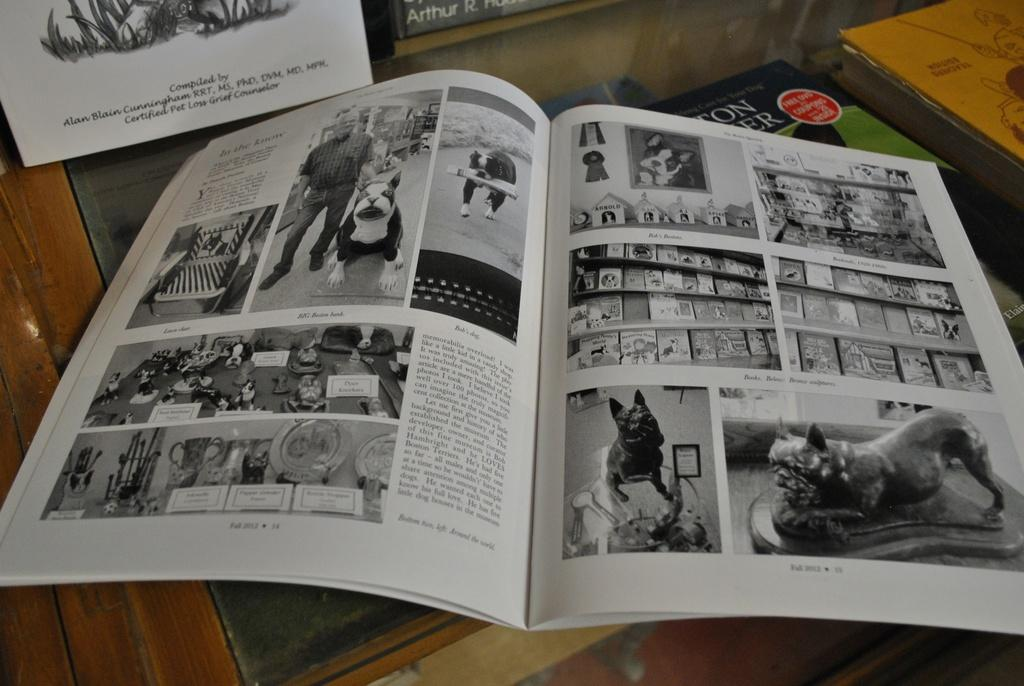<image>
Describe the image concisely. An open book with many pictures of dogs and trophies that is part of a display by a pet grief counselor. 